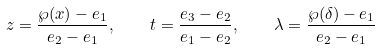<formula> <loc_0><loc_0><loc_500><loc_500>z = \frac { \wp ( x ) - e _ { 1 } } { e _ { 2 } - e _ { 1 } } , \quad t = \frac { e _ { 3 } - e _ { 2 } } { e _ { 1 } - e _ { 2 } } , \quad \lambda = \frac { \wp ( \delta ) - e _ { 1 } } { e _ { 2 } - e _ { 1 } }</formula> 